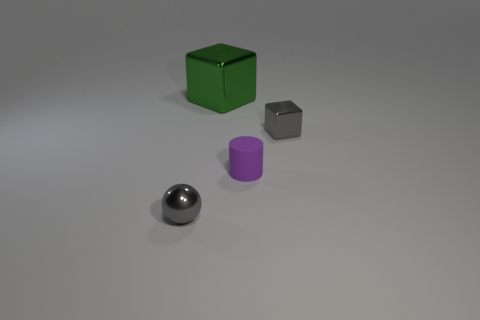Add 2 large yellow spheres. How many objects exist? 6 Subtract all spheres. How many objects are left? 3 Add 3 small rubber things. How many small rubber things are left? 4 Add 3 green metallic objects. How many green metallic objects exist? 4 Subtract 0 blue cubes. How many objects are left? 4 Subtract all tiny gray blocks. Subtract all rubber objects. How many objects are left? 2 